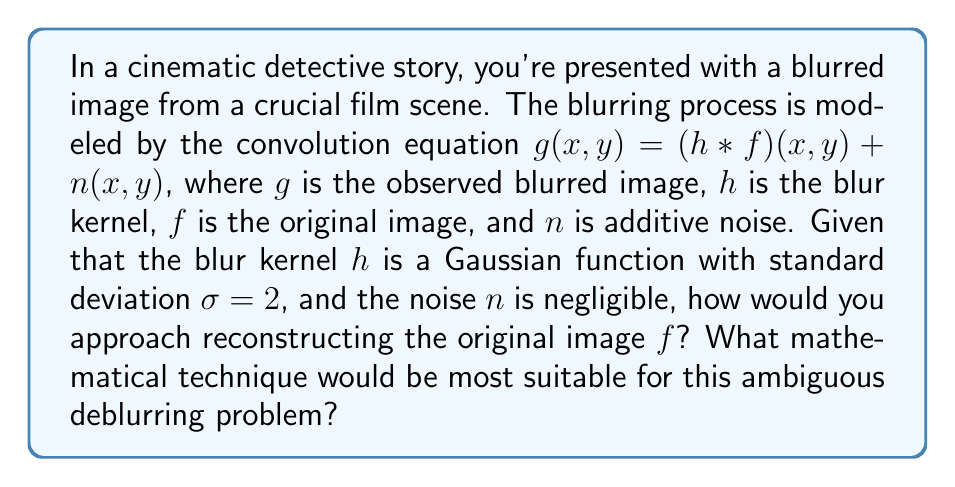Can you answer this question? To reconstruct the original image $f$ from the blurred image $g$, we need to solve an inverse problem. The steps to approach this are:

1. Recognize that this is a deconvolution problem, as the blurring is modeled by convolution.

2. Since the noise is negligible, we can focus on the equation:
   $$g = h * f$$

3. In the frequency domain, convolution becomes multiplication:
   $$G = H \cdot F$$
   where $G$, $H$, and $F$ are the Fourier transforms of $g$, $h$, and $f$ respectively.

4. Theoretically, we could solve for $F$ by division:
   $$F = G / H$$

5. However, direct division is ill-posed and can amplify noise. Instead, we should use regularization techniques.

6. A suitable method for this ambiguous problem is Tikhonov regularization, which solves:
   $$\min_F \|HF - G\|^2 + \lambda\|F\|^2$$
   where $\lambda$ is a regularization parameter controlling the trade-off between data fidelity and solution smoothness.

7. The solution to this regularized problem is:
   $$F = (H^*H + \lambda I)^{-1}H^*G$$
   where $H^*$ is the conjugate transpose of $H$ and $I$ is the identity matrix.

8. The inverse Fourier transform of $F$ gives the reconstructed image $f$.

This approach allows for controlled ambiguity in the reconstruction, which aligns with the film critic's appreciation for ambiguity in cinema.
Answer: Tikhonov regularization 